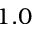<formula> <loc_0><loc_0><loc_500><loc_500>1 . 0</formula> 